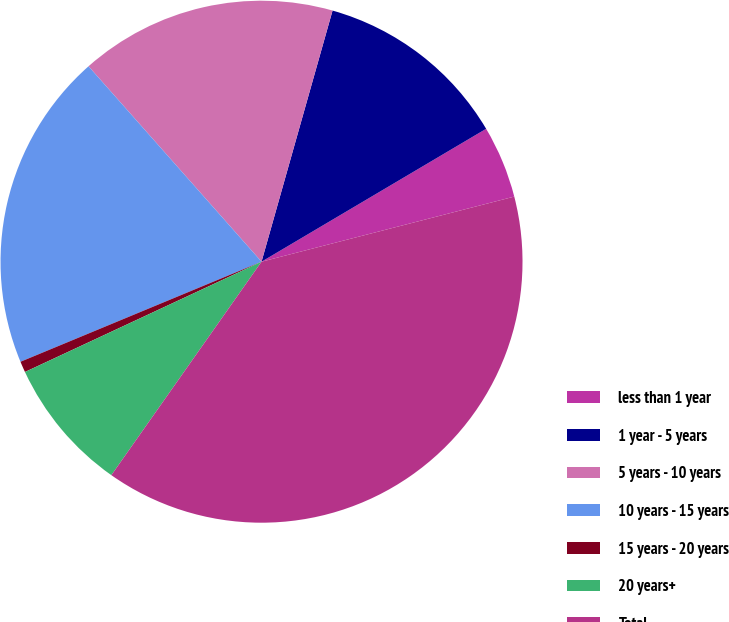Convert chart to OTSL. <chart><loc_0><loc_0><loc_500><loc_500><pie_chart><fcel>less than 1 year<fcel>1 year - 5 years<fcel>5 years - 10 years<fcel>10 years - 15 years<fcel>15 years - 20 years<fcel>20 years+<fcel>Total<nl><fcel>4.49%<fcel>12.11%<fcel>15.92%<fcel>19.73%<fcel>0.68%<fcel>8.3%<fcel>38.77%<nl></chart> 